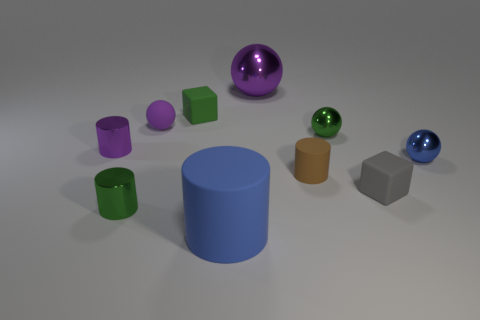Subtract all tiny green balls. How many balls are left? 3 Subtract all purple spheres. How many spheres are left? 2 Subtract all cylinders. How many objects are left? 6 Subtract all red blocks. How many purple cylinders are left? 1 Subtract all blue blocks. Subtract all large blue things. How many objects are left? 9 Add 3 blocks. How many blocks are left? 5 Add 7 tiny blue cubes. How many tiny blue cubes exist? 7 Subtract 1 green cubes. How many objects are left? 9 Subtract 1 spheres. How many spheres are left? 3 Subtract all green balls. Subtract all gray cylinders. How many balls are left? 3 